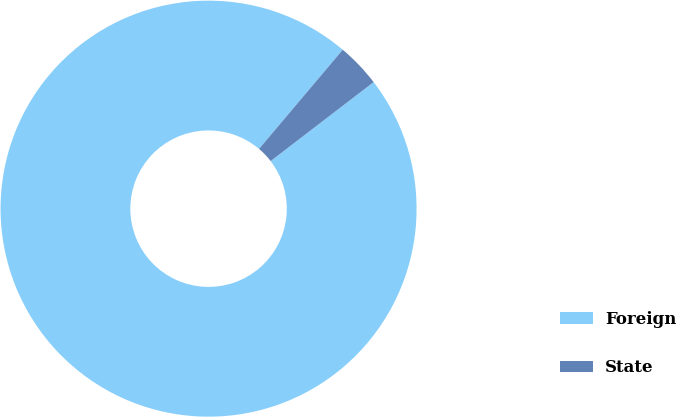Convert chart. <chart><loc_0><loc_0><loc_500><loc_500><pie_chart><fcel>Foreign<fcel>State<nl><fcel>96.57%<fcel>3.43%<nl></chart> 